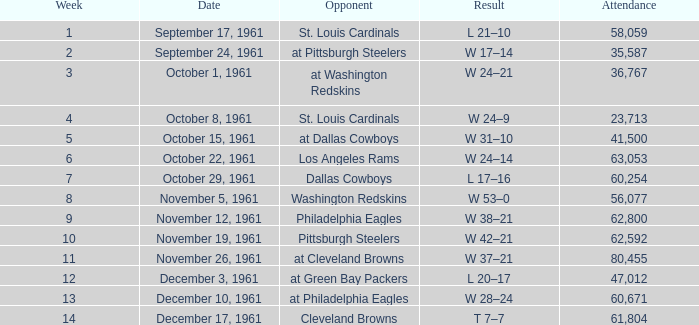Which Attendance has a Date of november 19, 1961? 62592.0. 